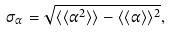Convert formula to latex. <formula><loc_0><loc_0><loc_500><loc_500>\sigma _ { \alpha } = \sqrt { \langle \langle \alpha ^ { 2 } \rangle \rangle - \langle \langle \alpha \rangle \rangle ^ { 2 } } ,</formula> 